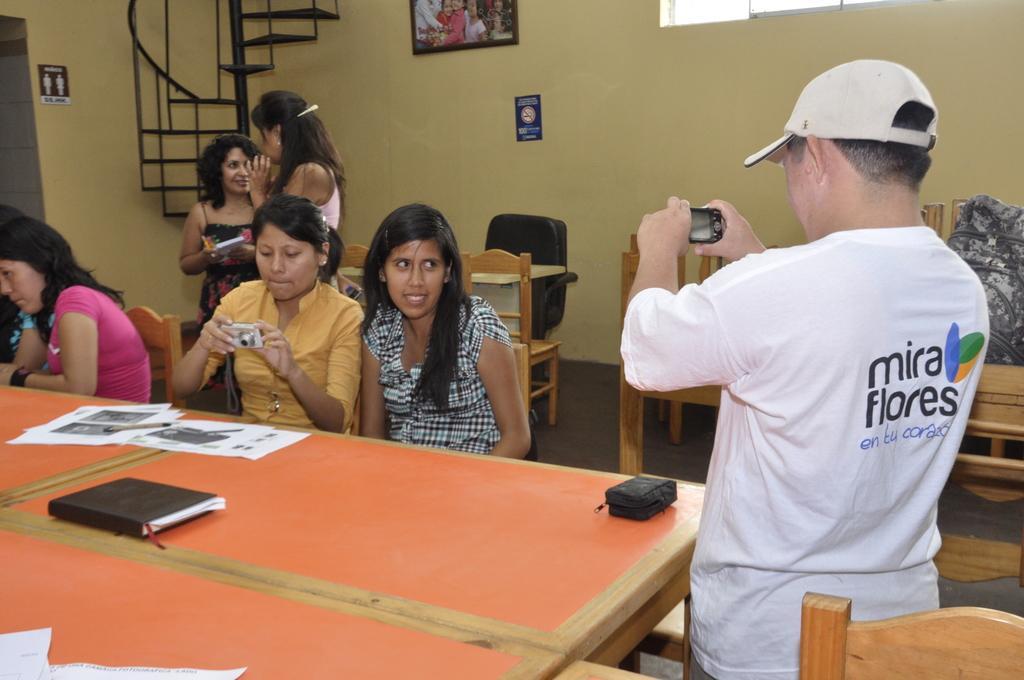Describe this image in one or two sentences. In this image we can see this person wearing white t-shirt is standing and holding a camera in his hands. This people are sitting on the chairs near the table. We can see papers, book and bag on the table. In the background we can see people standing, staircase, photo frame on wall and tables with chairs. 